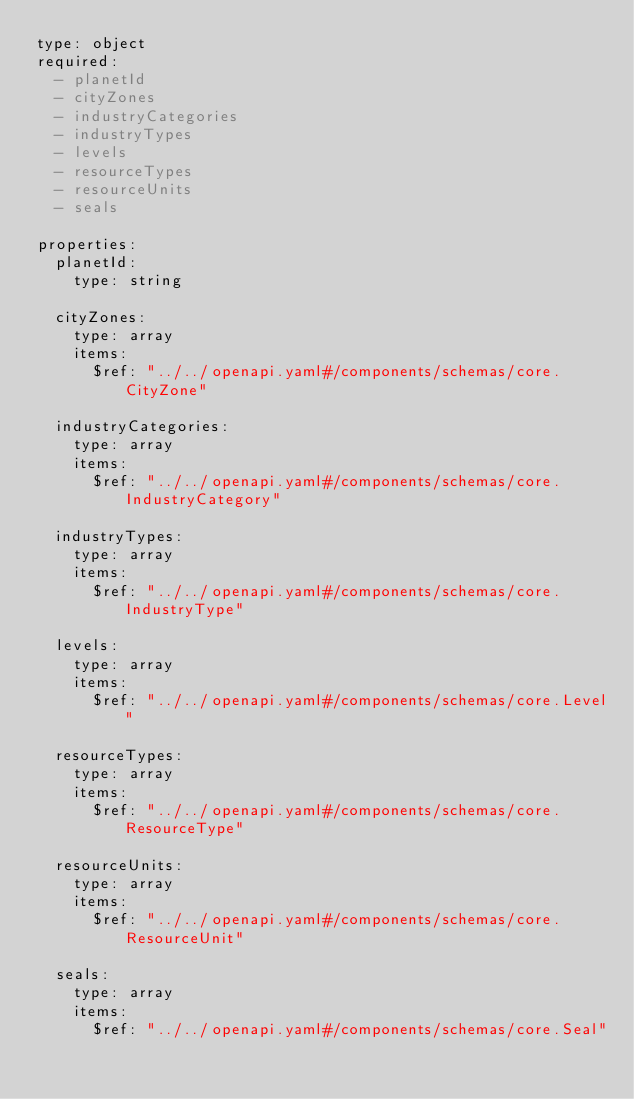Convert code to text. <code><loc_0><loc_0><loc_500><loc_500><_YAML_>type: object
required:
  - planetId
  - cityZones
  - industryCategories
  - industryTypes
  - levels
  - resourceTypes
  - resourceUnits
  - seals

properties:
  planetId:
    type: string

  cityZones:
    type: array
    items:
      $ref: "../../openapi.yaml#/components/schemas/core.CityZone"

  industryCategories:
    type: array
    items:
      $ref: "../../openapi.yaml#/components/schemas/core.IndustryCategory"

  industryTypes:
    type: array
    items:
      $ref: "../../openapi.yaml#/components/schemas/core.IndustryType"

  levels:
    type: array
    items:
      $ref: "../../openapi.yaml#/components/schemas/core.Level"

  resourceTypes:
    type: array
    items:
      $ref: "../../openapi.yaml#/components/schemas/core.ResourceType"

  resourceUnits:
    type: array
    items:
      $ref: "../../openapi.yaml#/components/schemas/core.ResourceUnit"

  seals:
    type: array
    items:
      $ref: "../../openapi.yaml#/components/schemas/core.Seal"
</code> 